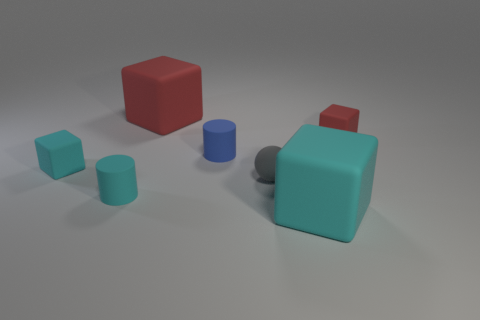Subtract all small cyan matte cubes. How many cubes are left? 3 Subtract all cyan cylinders. How many cylinders are left? 1 Subtract all blocks. How many objects are left? 3 Subtract 2 cubes. How many cubes are left? 2 Subtract all gray rubber balls. Subtract all rubber spheres. How many objects are left? 5 Add 1 cyan cylinders. How many cyan cylinders are left? 2 Add 1 large metallic balls. How many large metallic balls exist? 1 Add 1 big yellow metallic spheres. How many objects exist? 8 Subtract 0 red spheres. How many objects are left? 7 Subtract all red cubes. Subtract all red spheres. How many cubes are left? 2 